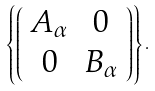Convert formula to latex. <formula><loc_0><loc_0><loc_500><loc_500>\left \{ \left ( \begin{array} { c c } A _ { \alpha } & 0 \\ 0 & B _ { \alpha } \end{array} \right ) \right \} .</formula> 